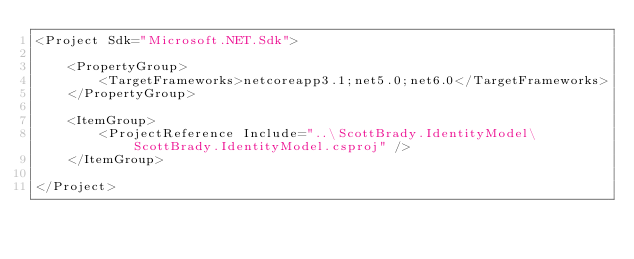Convert code to text. <code><loc_0><loc_0><loc_500><loc_500><_XML_><Project Sdk="Microsoft.NET.Sdk">

    <PropertyGroup>
        <TargetFrameworks>netcoreapp3.1;net5.0;net6.0</TargetFrameworks>
    </PropertyGroup>

    <ItemGroup>
        <ProjectReference Include="..\ScottBrady.IdentityModel\ScottBrady.IdentityModel.csproj" />
    </ItemGroup>

</Project>
</code> 